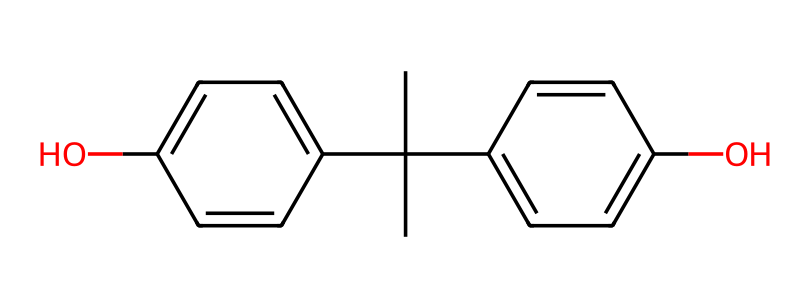What is the name of this chemical? The provided SMILES representation corresponds to bisphenol A (BPA), which is identified from the structure containing two aromatic rings and multiple hydroxyl (–OH) groups attached to them.
Answer: bisphenol A How many carbon atoms are in the structure? By examining the SMILES string, we can count the number of carbon (C) atoms explicitly present. The structure shows a total of 15 carbon atoms connected in the aromatic framework and the isopropyl groups.
Answer: 15 How many hydroxyl (–OH) groups are present? The SMILES notation indicates that there are two hydroxyl (–OH) groups attached to the aromatic rings in the structure, identifiable from the 'O' in the formula.
Answer: 2 What type of compound is BPA categorized as? BPA is classified as an aromatic compound due to the presence of two interconnected benzene rings, which is indicative of aromaticity.
Answer: aromatic What characteristic of the structure allows it to exhibit stability? The resonance stabilization in the aromatic rings due to delocalized pi electrons allows BPA to have enhanced stability, a key feature of aromatic compounds.
Answer: resonance stabilization Which functional group is present in this chemical? The presence of hydroxyl groups (–OH) in the structure indicates that BPA contains alcohol functional groups, which are critical for its properties and reactivity.
Answer: hydroxyl group How many rings are present in the structure? The examination of the SMILES reveals that there are two distinct aromatic rings, characteristic of the bisphenol structure.
Answer: 2 